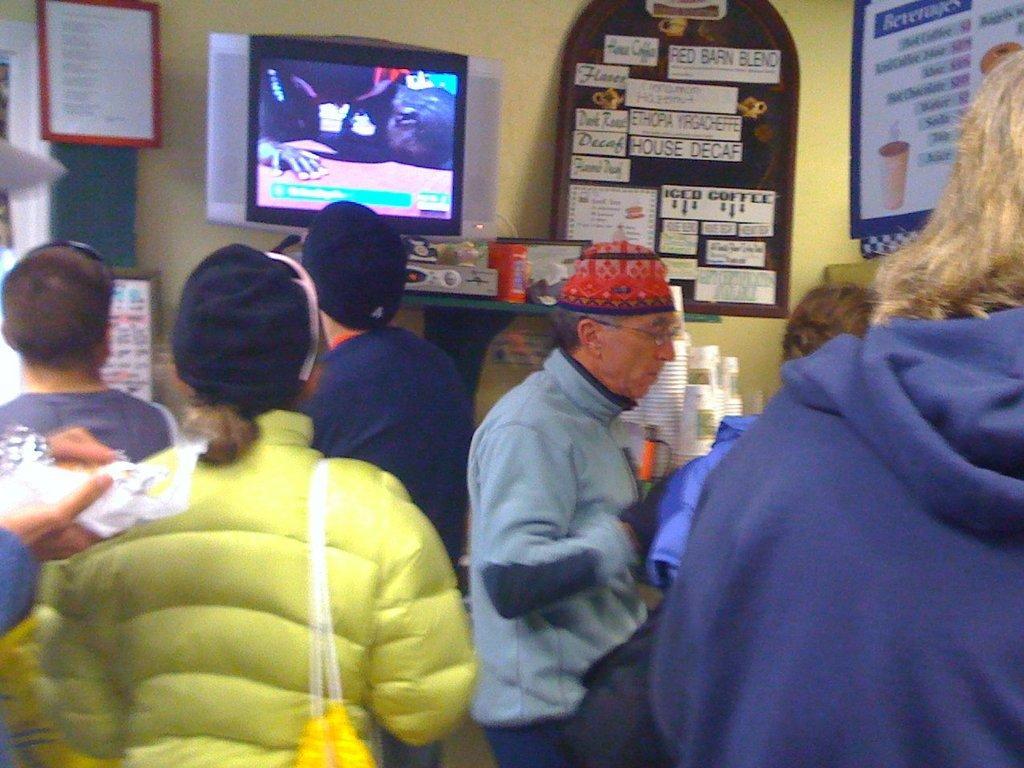How would you summarize this image in a sentence or two? In the image we can see there are many people around, they are wearing clothes and some of them are wearing caps. Here we can see television screen and the boards. Here we can see the text on the board and the glasses 